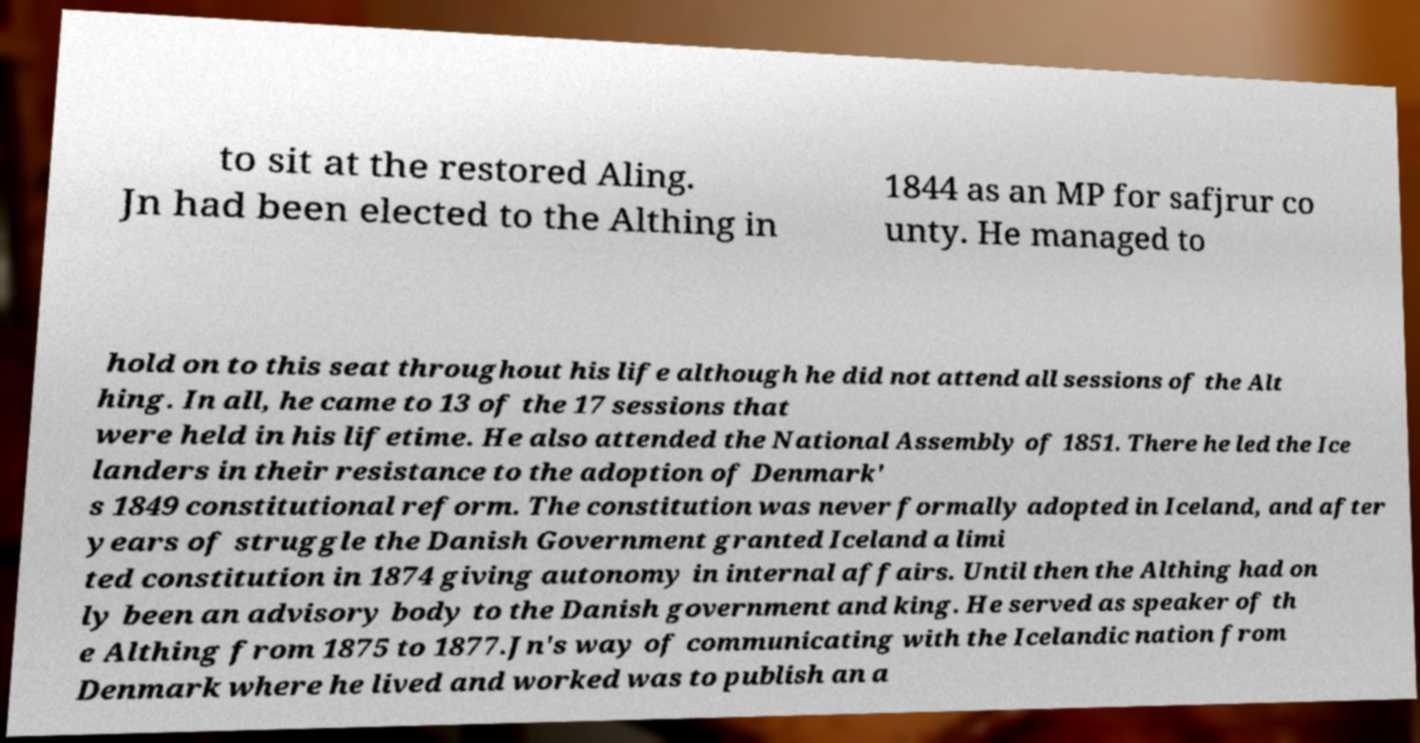Could you assist in decoding the text presented in this image and type it out clearly? to sit at the restored Aling. Jn had been elected to the Althing in 1844 as an MP for safjrur co unty. He managed to hold on to this seat throughout his life although he did not attend all sessions of the Alt hing. In all, he came to 13 of the 17 sessions that were held in his lifetime. He also attended the National Assembly of 1851. There he led the Ice landers in their resistance to the adoption of Denmark' s 1849 constitutional reform. The constitution was never formally adopted in Iceland, and after years of struggle the Danish Government granted Iceland a limi ted constitution in 1874 giving autonomy in internal affairs. Until then the Althing had on ly been an advisory body to the Danish government and king. He served as speaker of th e Althing from 1875 to 1877.Jn's way of communicating with the Icelandic nation from Denmark where he lived and worked was to publish an a 